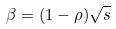Convert formula to latex. <formula><loc_0><loc_0><loc_500><loc_500>\beta = ( 1 - \rho ) \sqrt { s }</formula> 